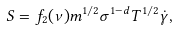<formula> <loc_0><loc_0><loc_500><loc_500>S = f _ { 2 } ( \nu ) m ^ { 1 / 2 } \sigma ^ { 1 - d } T ^ { 1 / 2 } \dot { \gamma } ,</formula> 